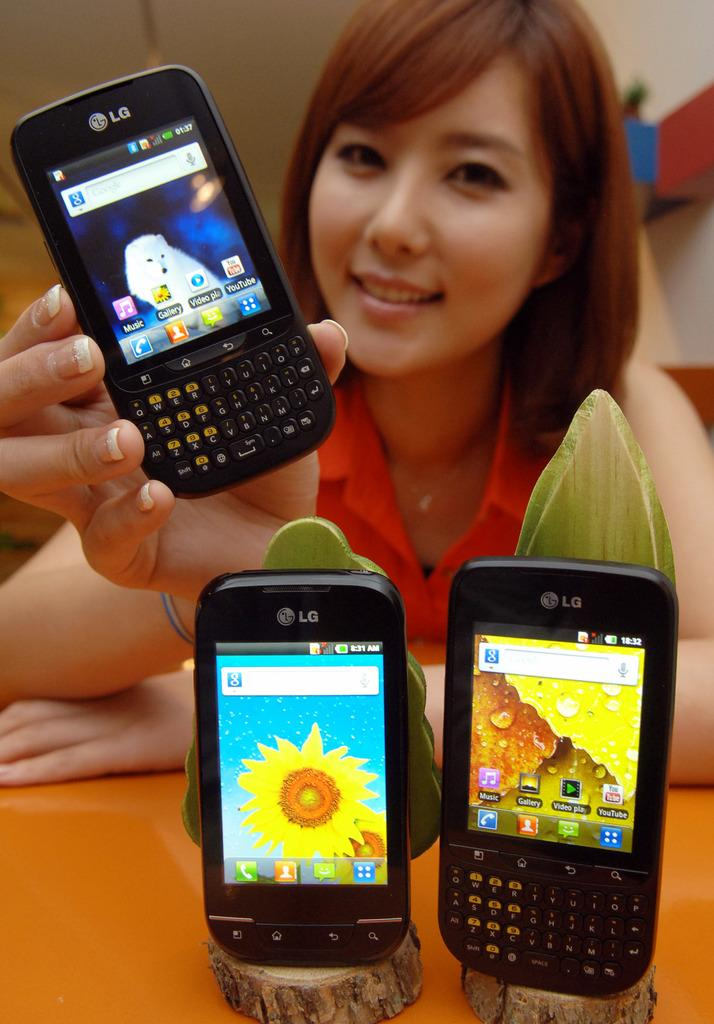<image>
Render a clear and concise summary of the photo. A girl posing with three phones, all of which have LG written on them./ 